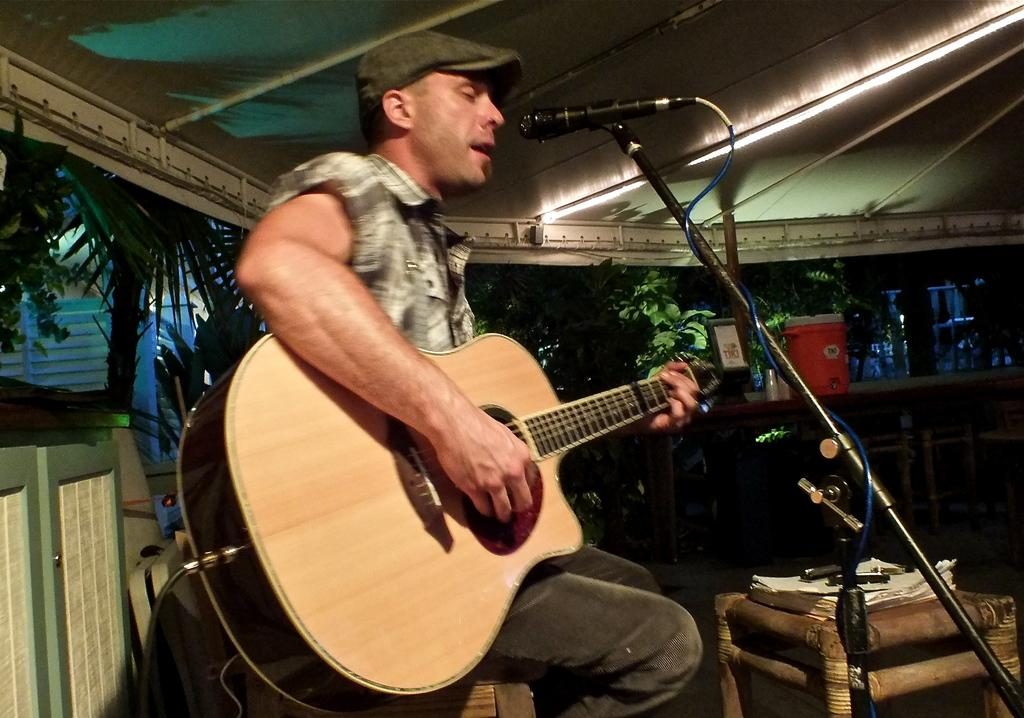What is the main subject of the image? There is a man in the image. What is the man doing in the image? The man is singing. How is the man holding the guitar in the image? The man is holding the guitar with his left hand. What is the man doing with his right hand in the image? The man is playing the guitar with his right hand. What type of beef is the man eating in the image? There is no beef present in the image; the man is holding a guitar and singing. How many eyes does the man have in the image? The man has two eyes in the image, but this question is irrelevant to the main subject and actions depicted. 